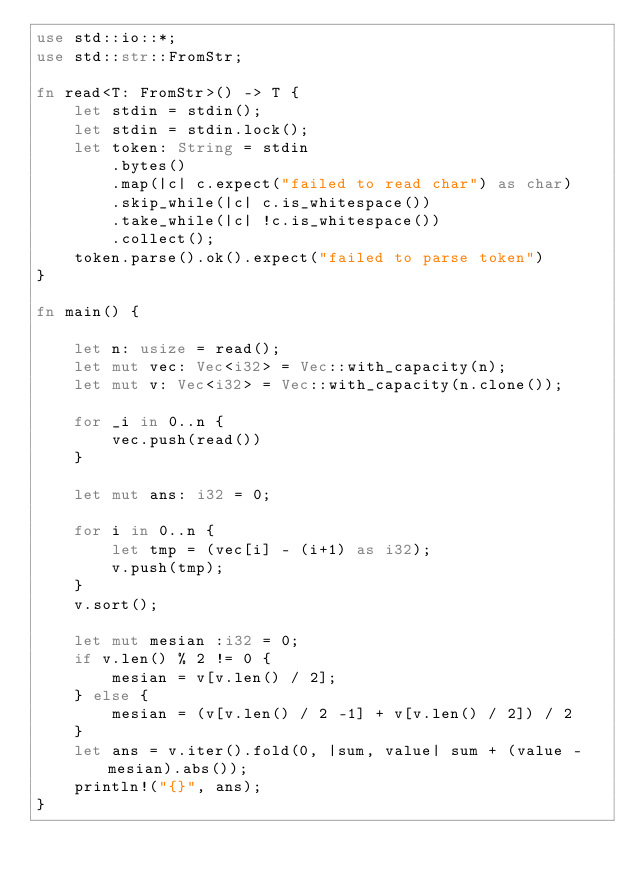Convert code to text. <code><loc_0><loc_0><loc_500><loc_500><_Rust_>use std::io::*;
use std::str::FromStr;

fn read<T: FromStr>() -> T {
    let stdin = stdin();
    let stdin = stdin.lock();
    let token: String = stdin
        .bytes()
        .map(|c| c.expect("failed to read char") as char)
        .skip_while(|c| c.is_whitespace())
        .take_while(|c| !c.is_whitespace())
        .collect();
    token.parse().ok().expect("failed to parse token")
}

fn main() {

    let n: usize = read();
    let mut vec: Vec<i32> = Vec::with_capacity(n);
    let mut v: Vec<i32> = Vec::with_capacity(n.clone());

    for _i in 0..n {
        vec.push(read())
    }

    let mut ans: i32 = 0;

    for i in 0..n {
        let tmp = (vec[i] - (i+1) as i32);
        v.push(tmp);
    }
    v.sort();

    let mut mesian :i32 = 0;
    if v.len() % 2 != 0 {
        mesian = v[v.len() / 2];
    } else {
        mesian = (v[v.len() / 2 -1] + v[v.len() / 2]) / 2
    }
    let ans = v.iter().fold(0, |sum, value| sum + (value - mesian).abs());
    println!("{}", ans);
}

</code> 